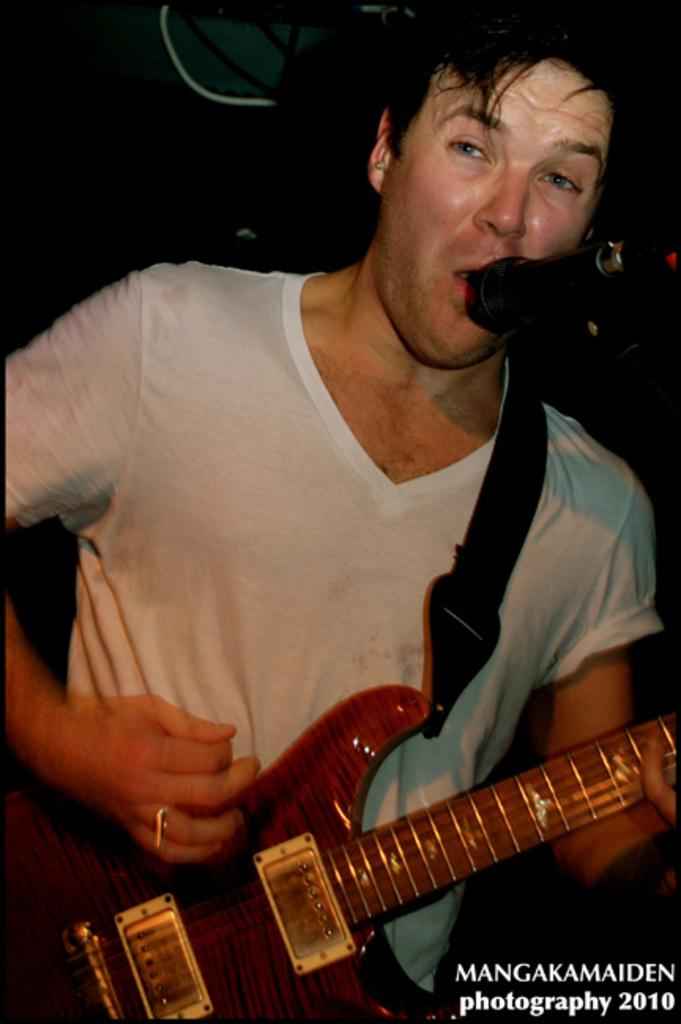Who is the main subject in the image? There is a man in the image. What is the man doing in the image? The man is standing, playing a guitar, and singing into a microphone. What type of honey is the man using to sweeten his voice while singing in the image? There is no honey present in the image, and the man is not using any substance to sweeten his voice while singing. 